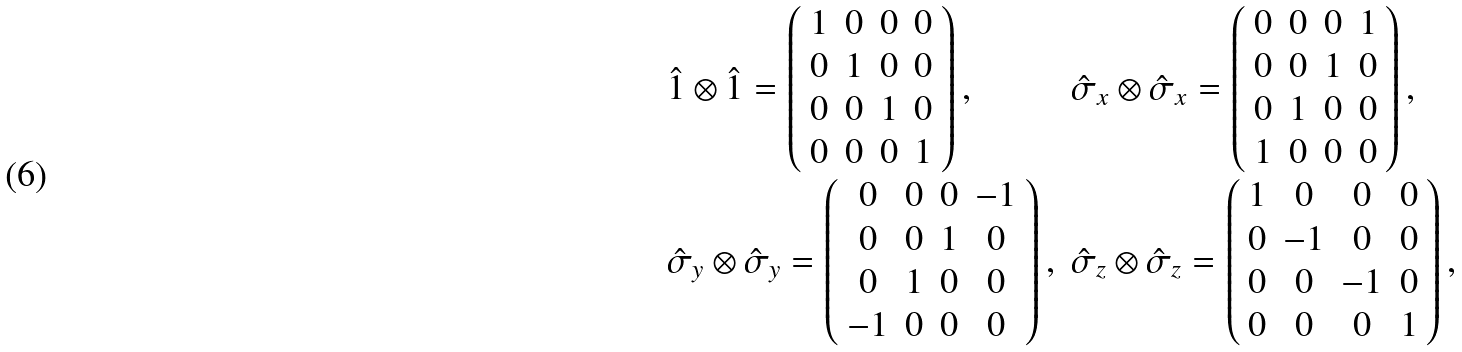Convert formula to latex. <formula><loc_0><loc_0><loc_500><loc_500>\begin{array} { l l } \hat { 1 } \otimes \hat { 1 } = \left ( \begin{array} { c c c c } 1 & 0 & 0 & 0 \\ 0 & 1 & 0 & 0 \\ 0 & 0 & 1 & 0 \\ 0 & 0 & 0 & 1 \\ \end{array} \right ) , & \hat { \sigma } _ { x } \otimes \hat { \sigma } _ { x } = \left ( \begin{array} { c c c c } 0 & 0 & 0 & 1 \\ 0 & 0 & 1 & 0 \\ 0 & 1 & 0 & 0 \\ 1 & 0 & 0 & 0 \\ \end{array} \right ) , \\ \hat { \sigma } _ { y } \otimes \hat { \sigma } _ { y } = \left ( \begin{array} { c c c c } 0 & 0 & 0 & - 1 \\ 0 & 0 & 1 & 0 \\ 0 & 1 & 0 & 0 \\ - 1 & 0 & 0 & 0 \\ \end{array} \right ) , & \hat { \sigma } _ { z } \otimes \hat { \sigma } _ { z } = \left ( \begin{array} { c c c c } 1 & 0 & 0 & 0 \\ 0 & - 1 & 0 & 0 \\ 0 & 0 & - 1 & 0 \\ 0 & 0 & 0 & 1 \\ \end{array} \right ) , \end{array}</formula> 